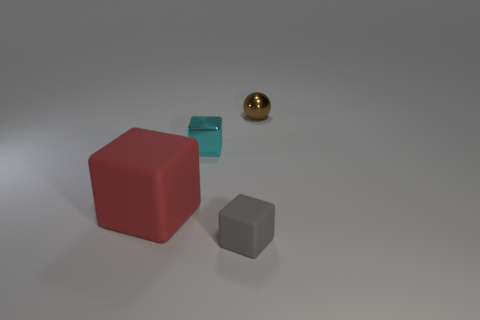What shape is the brown metal object that is the same size as the cyan cube?
Your response must be concise. Sphere. Is there a matte block that has the same color as the tiny metallic ball?
Provide a short and direct response. No. Are there the same number of red things that are to the left of the large red matte object and red matte blocks?
Your answer should be compact. No. Does the tiny rubber block have the same color as the small ball?
Provide a short and direct response. No. There is a cube that is in front of the cyan metal thing and left of the small rubber block; how big is it?
Provide a short and direct response. Large. There is another thing that is made of the same material as the big red thing; what is its color?
Your response must be concise. Gray. What number of gray cubes are made of the same material as the tiny brown object?
Give a very brief answer. 0. Are there the same number of big cubes right of the gray rubber object and cyan metallic things to the left of the small brown thing?
Your response must be concise. No. There is a small gray thing; does it have the same shape as the metal thing in front of the tiny shiny sphere?
Make the answer very short. Yes. Is there anything else that has the same shape as the tiny gray matte thing?
Ensure brevity in your answer.  Yes. 